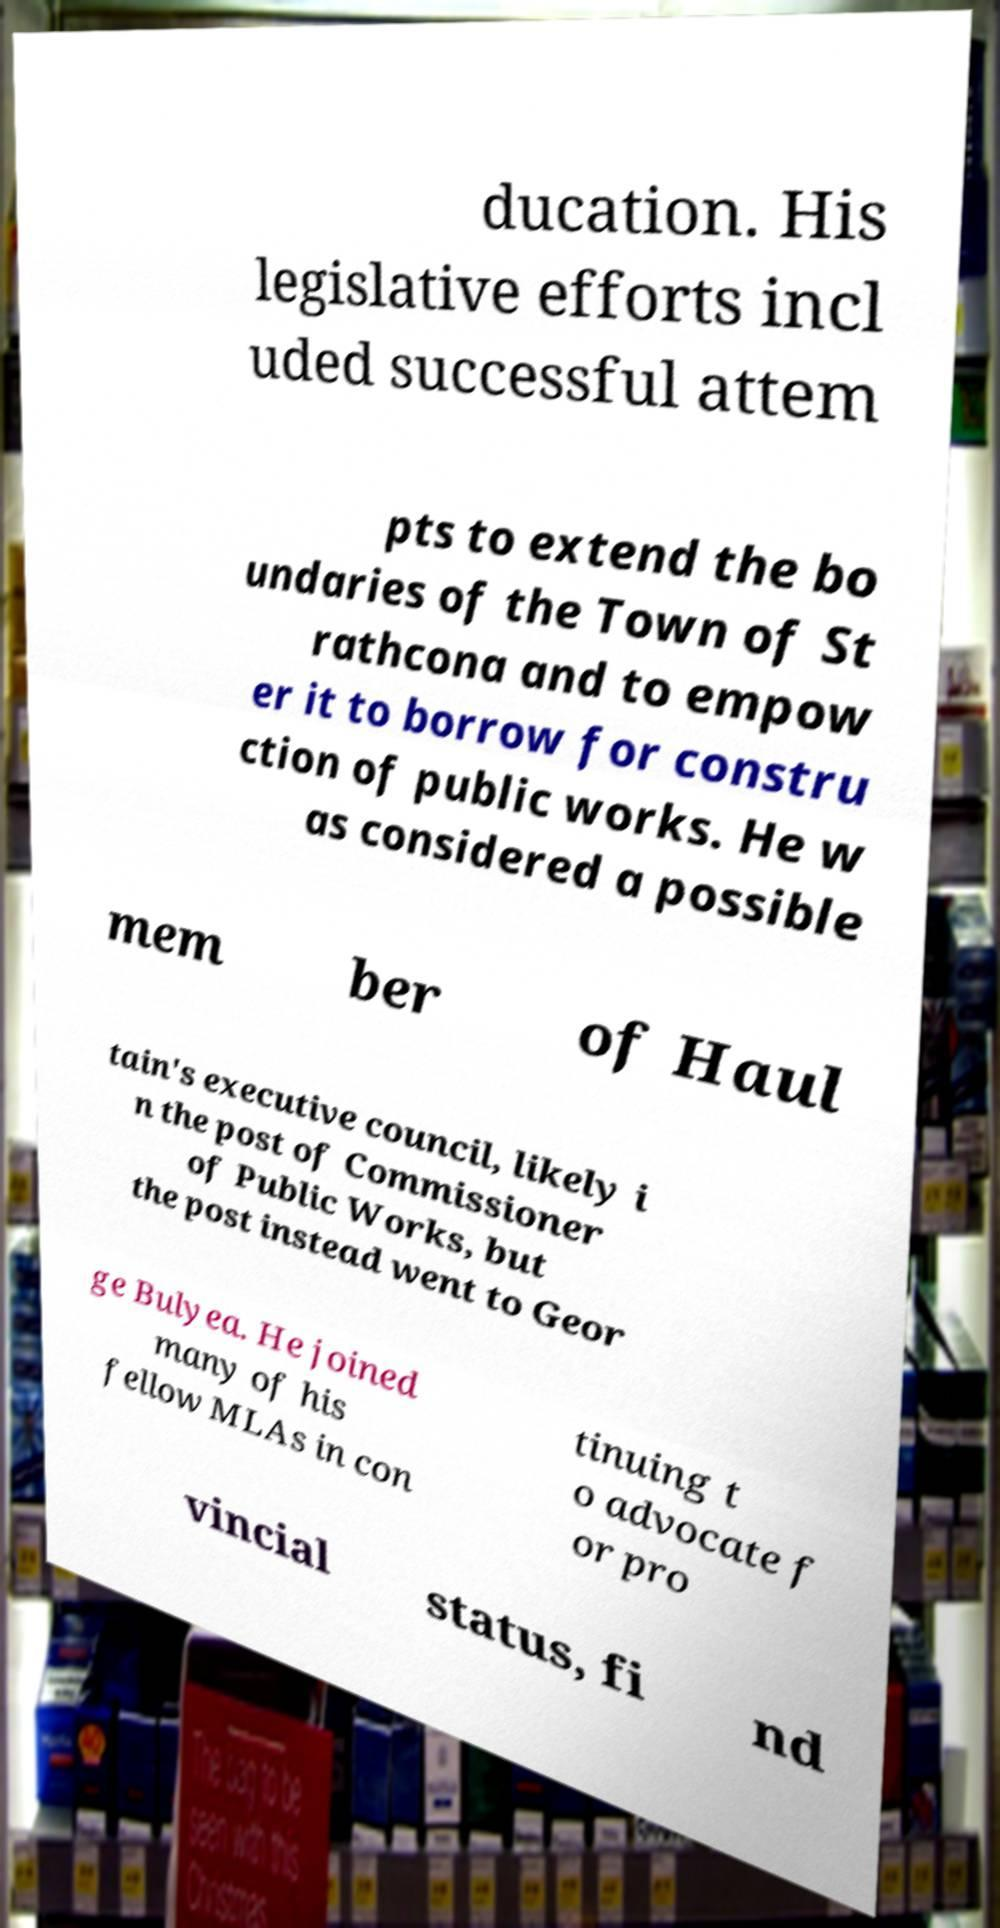Could you extract and type out the text from this image? ducation. His legislative efforts incl uded successful attem pts to extend the bo undaries of the Town of St rathcona and to empow er it to borrow for constru ction of public works. He w as considered a possible mem ber of Haul tain's executive council, likely i n the post of Commissioner of Public Works, but the post instead went to Geor ge Bulyea. He joined many of his fellow MLAs in con tinuing t o advocate f or pro vincial status, fi nd 